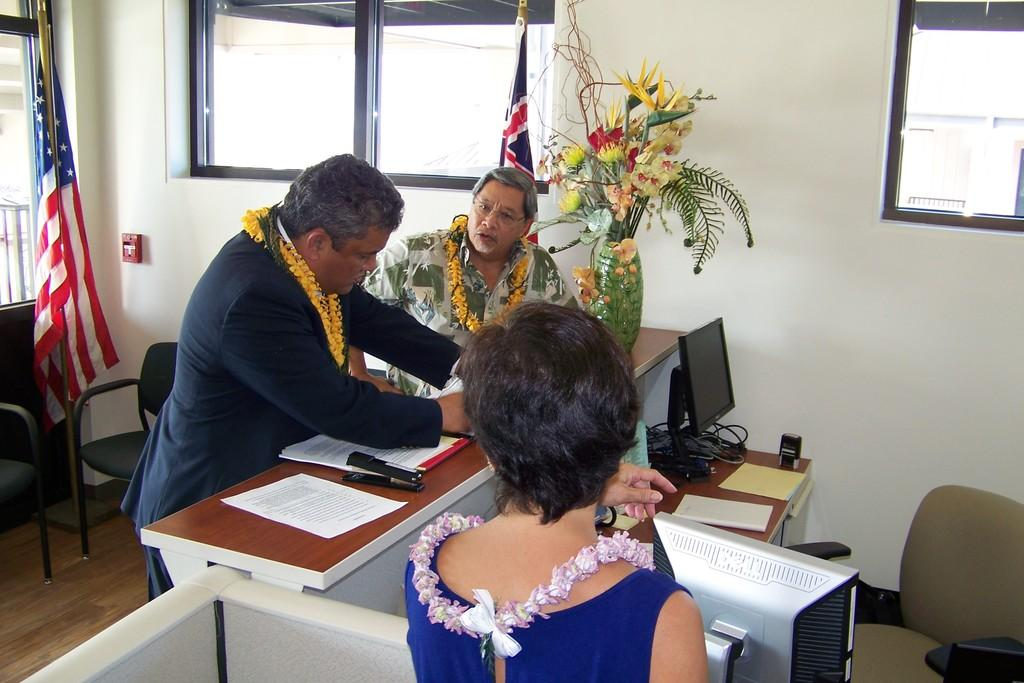How many people are in the room in the image? There are two men and one woman in the room, making a total of three people. What are the people in the room doing? The people are standing in front of a table. What is on the table in the image? There are chairs on the table, as well as different items. What is the condition of the foot in the image? There is no foot visible in the image. How many cents are present in the image? There is no mention of currency or cents in the image. 